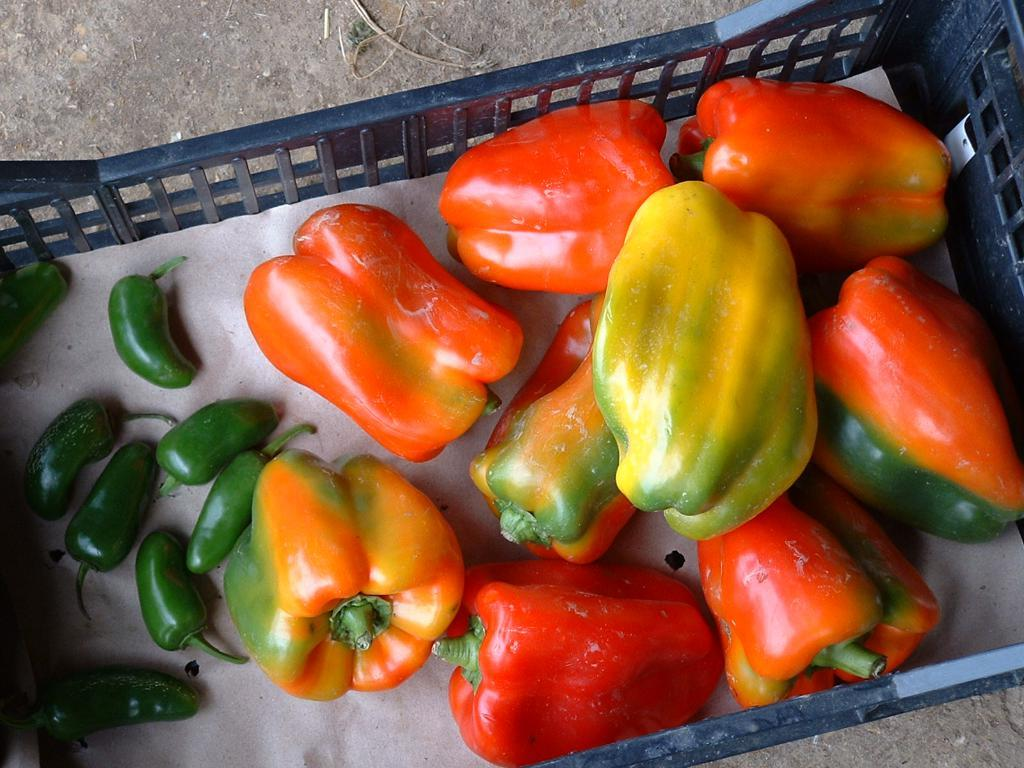What type of vegetables are present in the image? There are capsicums and chillies in the image. What is used to hold the vegetables in the image? There is a tray in the image. What is the surface on which the tray is placed? There is a pad in the image. What can be seen below the pad in the image? The floor is visible in the image. What type of sugar is being used to decorate the desk in the image? There is no sugar or desk present in the image; it features capsicums, chillies, a tray, and a pad. 